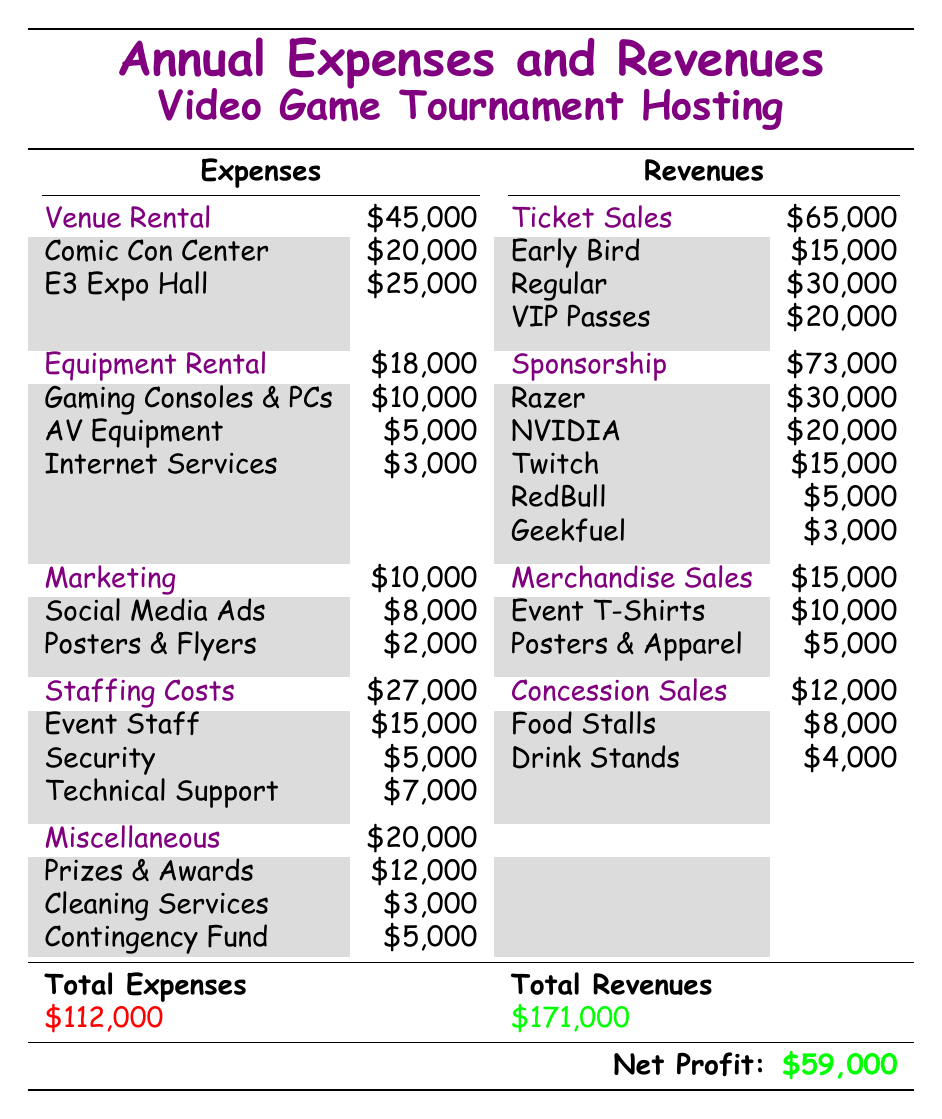What are the total expenses for the venue rental? The table shows two venue rental costs: Comic Con Convention Center at 20,000 and E3 Expo Hall at 25,000. Adding these together gives us 20,000 + 25,000 = 45,000.
Answer: 45,000 What were the ticket sales from VIP passes? According to the table, ticket sales from VIP passes amount to 20,000.
Answer: 20,000 Is the total revenue greater than the total expenses? The total revenues listed in the table is 171,000, while the total expenses are 112,000. Since 171,000 is greater than 112,000, this is true.
Answer: Yes What is the net profit calculated from the total revenues and total expenses? The net profit can be found by subtracting total expenses (112,000) from total revenues (171,000). Therefore, 171,000 - 112,000 results in 59,000, which is confirmed as the net profit in the table.
Answer: 59,000 How much did the event spend on staffing costs compared to marketing? Staffing costs total 27,000 and marketing costs total 10,000. To compare, we can see that staffing costs exceeded marketing costs by 27,000 - 10,000 = 17,000.
Answer: 17,000 What was the total income from merchandise sales? The total income from merchandise sales includes event T-shirts (10,000) and posters and apparel (5,000). Adding both gives 10,000 + 5,000 = 15,000, which is reflected in the table.
Answer: 15,000 Did the sponsorship income from Razer go beyond 25,000? The table lists Razer's sponsorship at 30,000. Since 30,000 is greater than 25,000, the answer is affirmative.
Answer: Yes What is the total amount spent on miscellaneous expenses? Miscellaneous expenses include prizes and awards (12,000), cleaning services (3,000), and a contingency fund (5,000). Adding these up gives 12,000 + 3,000 + 5,000 = 20,000 in total miscellaneous expenses.
Answer: 20,000 What is the total revenue from snack and drink sales? The total revenue from concession sales is derived from food stalls (8,000) and drink stands (4,000). Adding these gives 8,000 + 4,000 = 12,000, which is recorded in the table under concession sales.
Answer: 12,000 